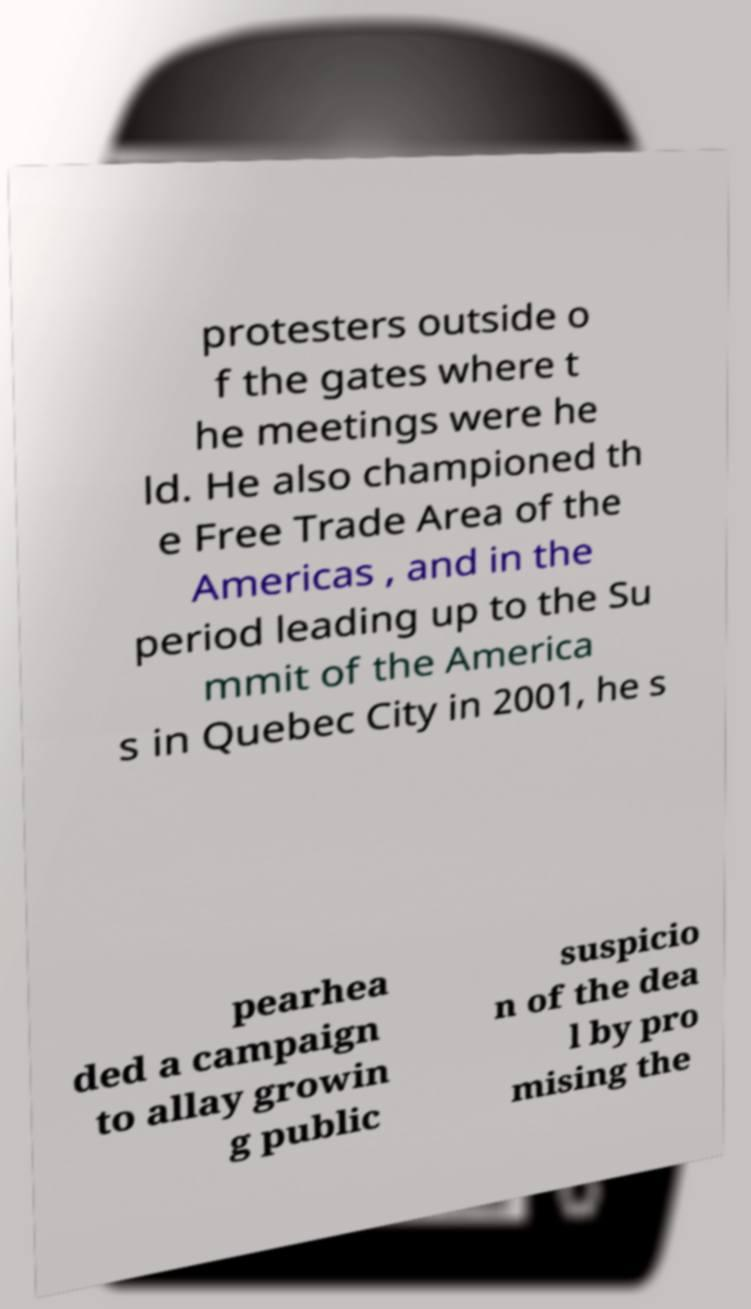I need the written content from this picture converted into text. Can you do that? protesters outside o f the gates where t he meetings were he ld. He also championed th e Free Trade Area of the Americas , and in the period leading up to the Su mmit of the America s in Quebec City in 2001, he s pearhea ded a campaign to allay growin g public suspicio n of the dea l by pro mising the 